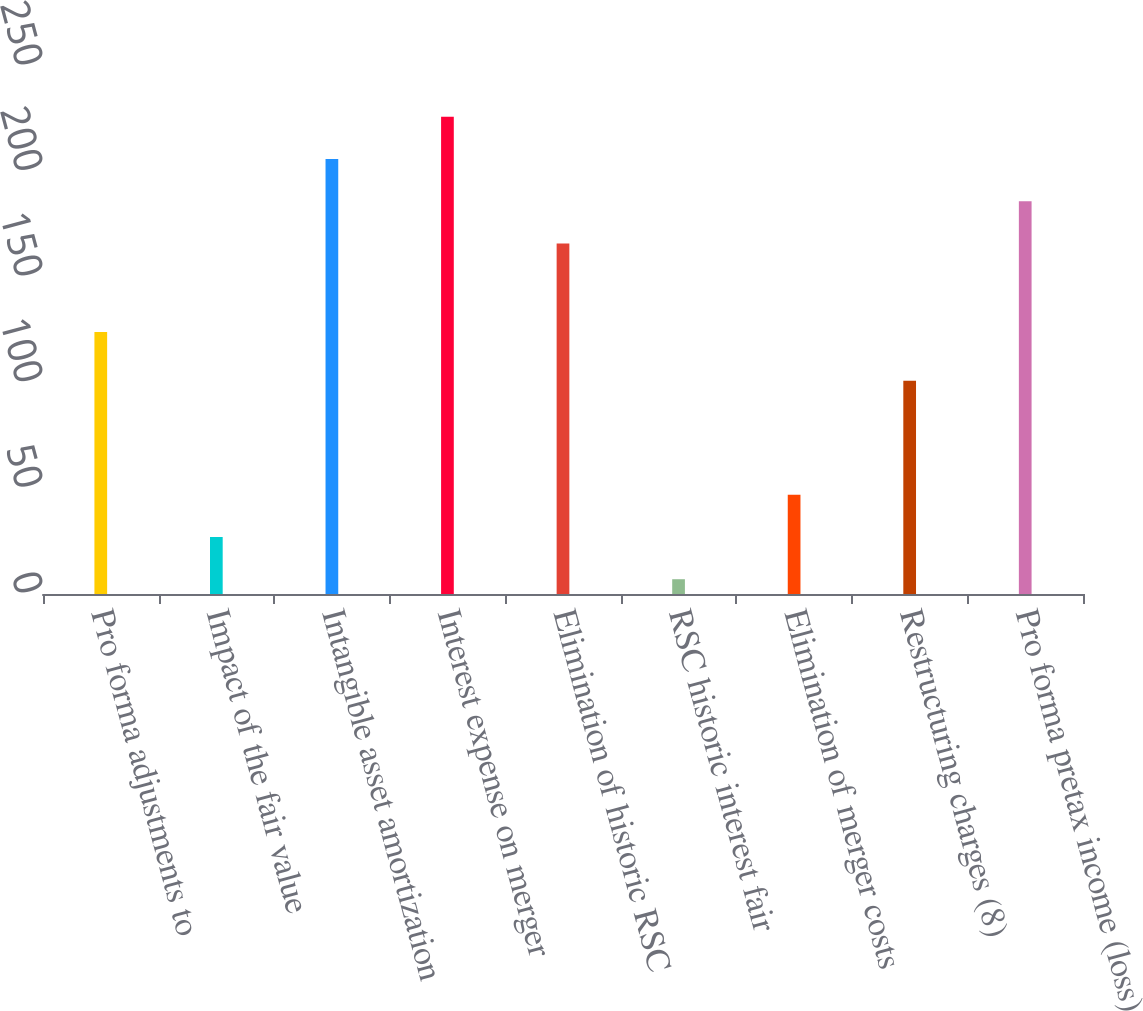Convert chart. <chart><loc_0><loc_0><loc_500><loc_500><bar_chart><fcel>Pro forma adjustments to<fcel>Impact of the fair value<fcel>Intangible asset amortization<fcel>Interest expense on merger<fcel>Elimination of historic RSC<fcel>RSC historic interest fair<fcel>Elimination of merger costs<fcel>Restructuring charges (8)<fcel>Pro forma pretax income (loss)<nl><fcel>124<fcel>27<fcel>206<fcel>226<fcel>166<fcel>7<fcel>47<fcel>101<fcel>186<nl></chart> 